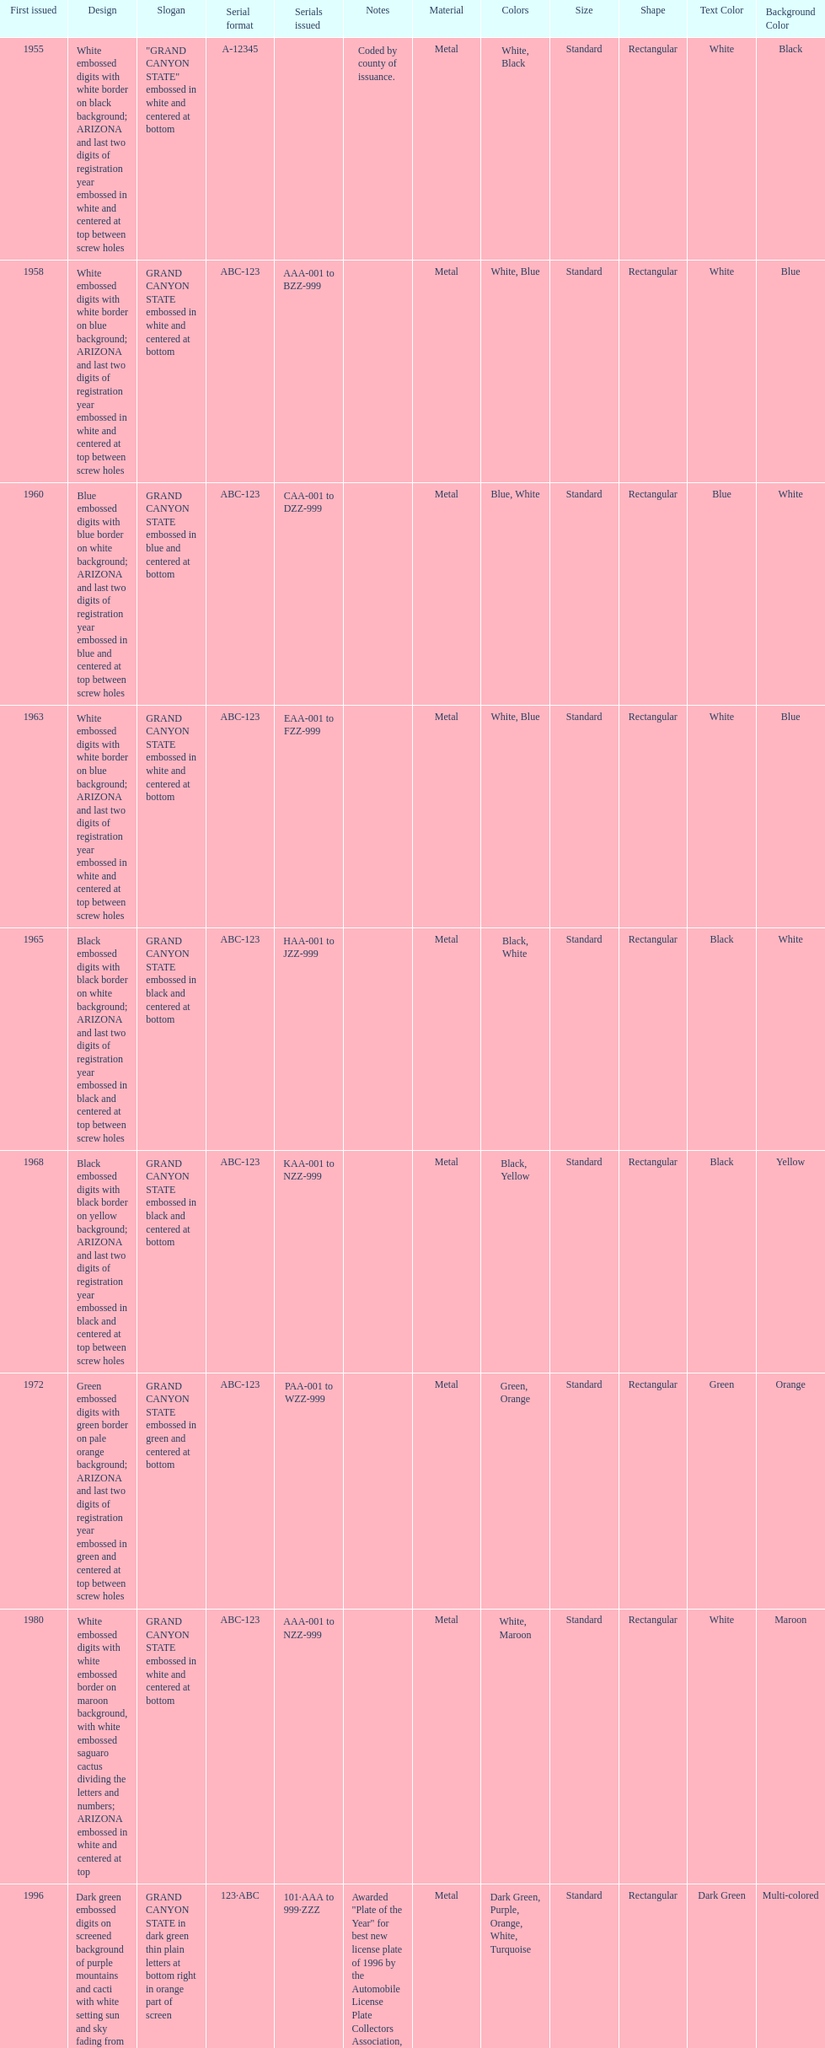Which year featured the license plate with the least characters? 1955. 